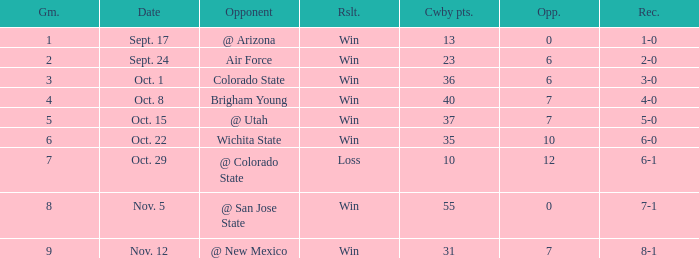When did the Cowboys score 13 points in 1966? Sept. 17. 